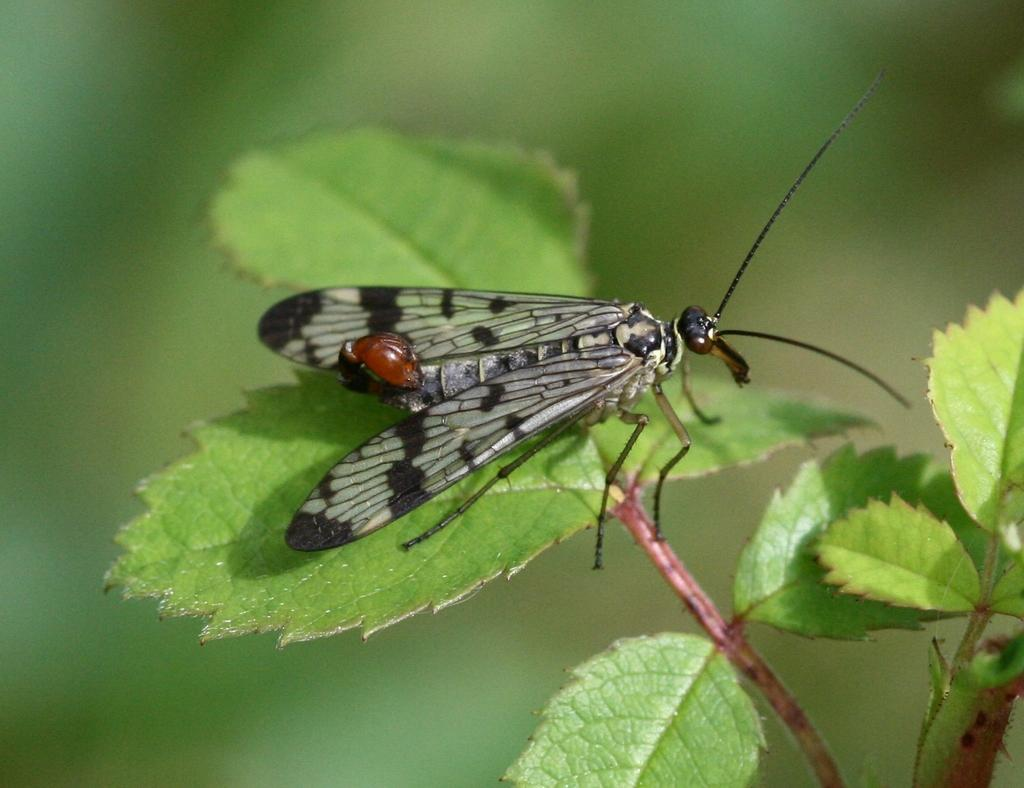What is present on the leaf in the image? There is an insect on a leaf in the image. Can you describe the background of the image? The background of the image is blurred. What type of silver material can be seen on the leaf in the image? There is no silver material present on the leaf in the image; it features an insect on a leaf. Are there any fairies visible in the image? There are no fairies present in the image; it features an insect on a leaf. 